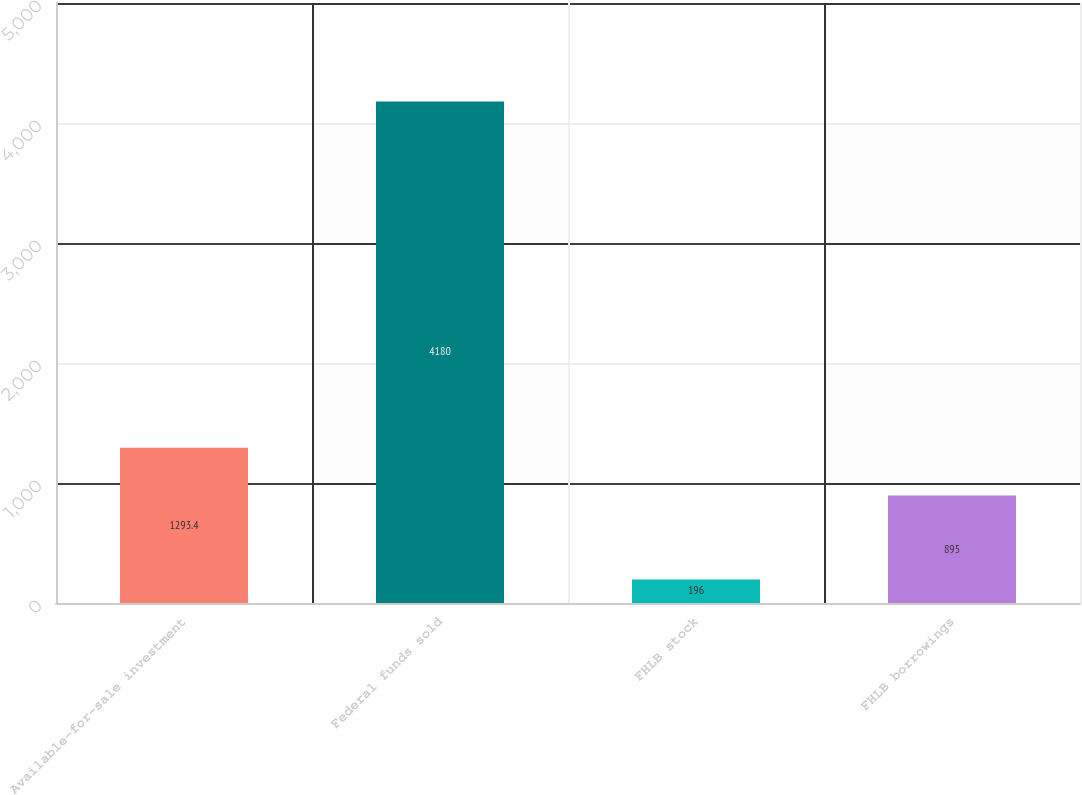Convert chart to OTSL. <chart><loc_0><loc_0><loc_500><loc_500><bar_chart><fcel>Available-for-sale investment<fcel>Federal funds sold<fcel>FHLB stock<fcel>FHLB borrowings<nl><fcel>1293.4<fcel>4180<fcel>196<fcel>895<nl></chart> 